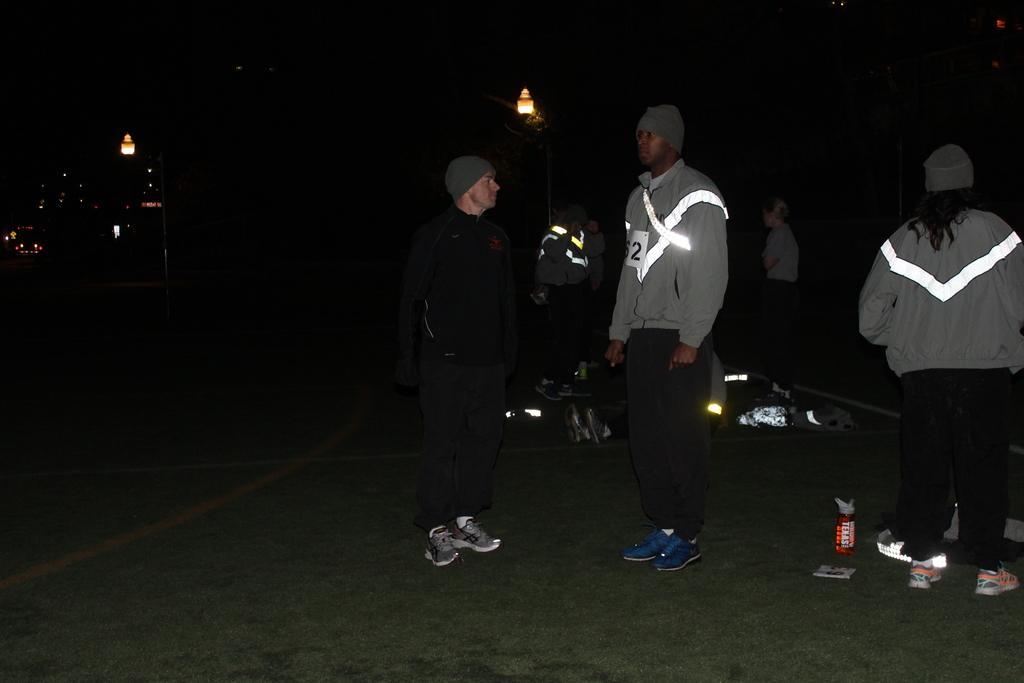Can you describe this image briefly? In this picture we can see a group of people wore caps, shoes and standing on the ground, lights and some objects and in the background it is dark. 